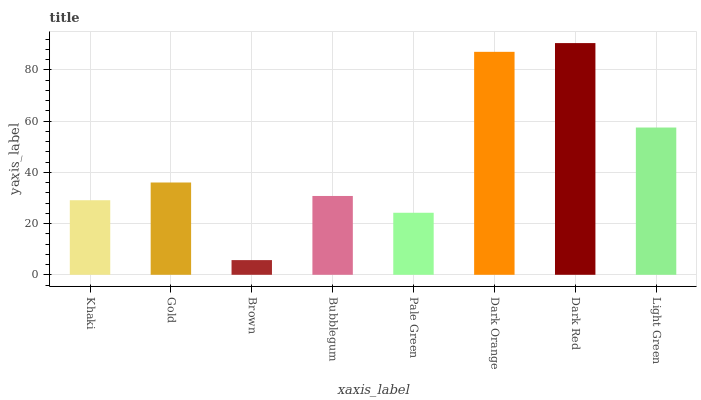Is Brown the minimum?
Answer yes or no. Yes. Is Dark Red the maximum?
Answer yes or no. Yes. Is Gold the minimum?
Answer yes or no. No. Is Gold the maximum?
Answer yes or no. No. Is Gold greater than Khaki?
Answer yes or no. Yes. Is Khaki less than Gold?
Answer yes or no. Yes. Is Khaki greater than Gold?
Answer yes or no. No. Is Gold less than Khaki?
Answer yes or no. No. Is Gold the high median?
Answer yes or no. Yes. Is Bubblegum the low median?
Answer yes or no. Yes. Is Dark Orange the high median?
Answer yes or no. No. Is Brown the low median?
Answer yes or no. No. 